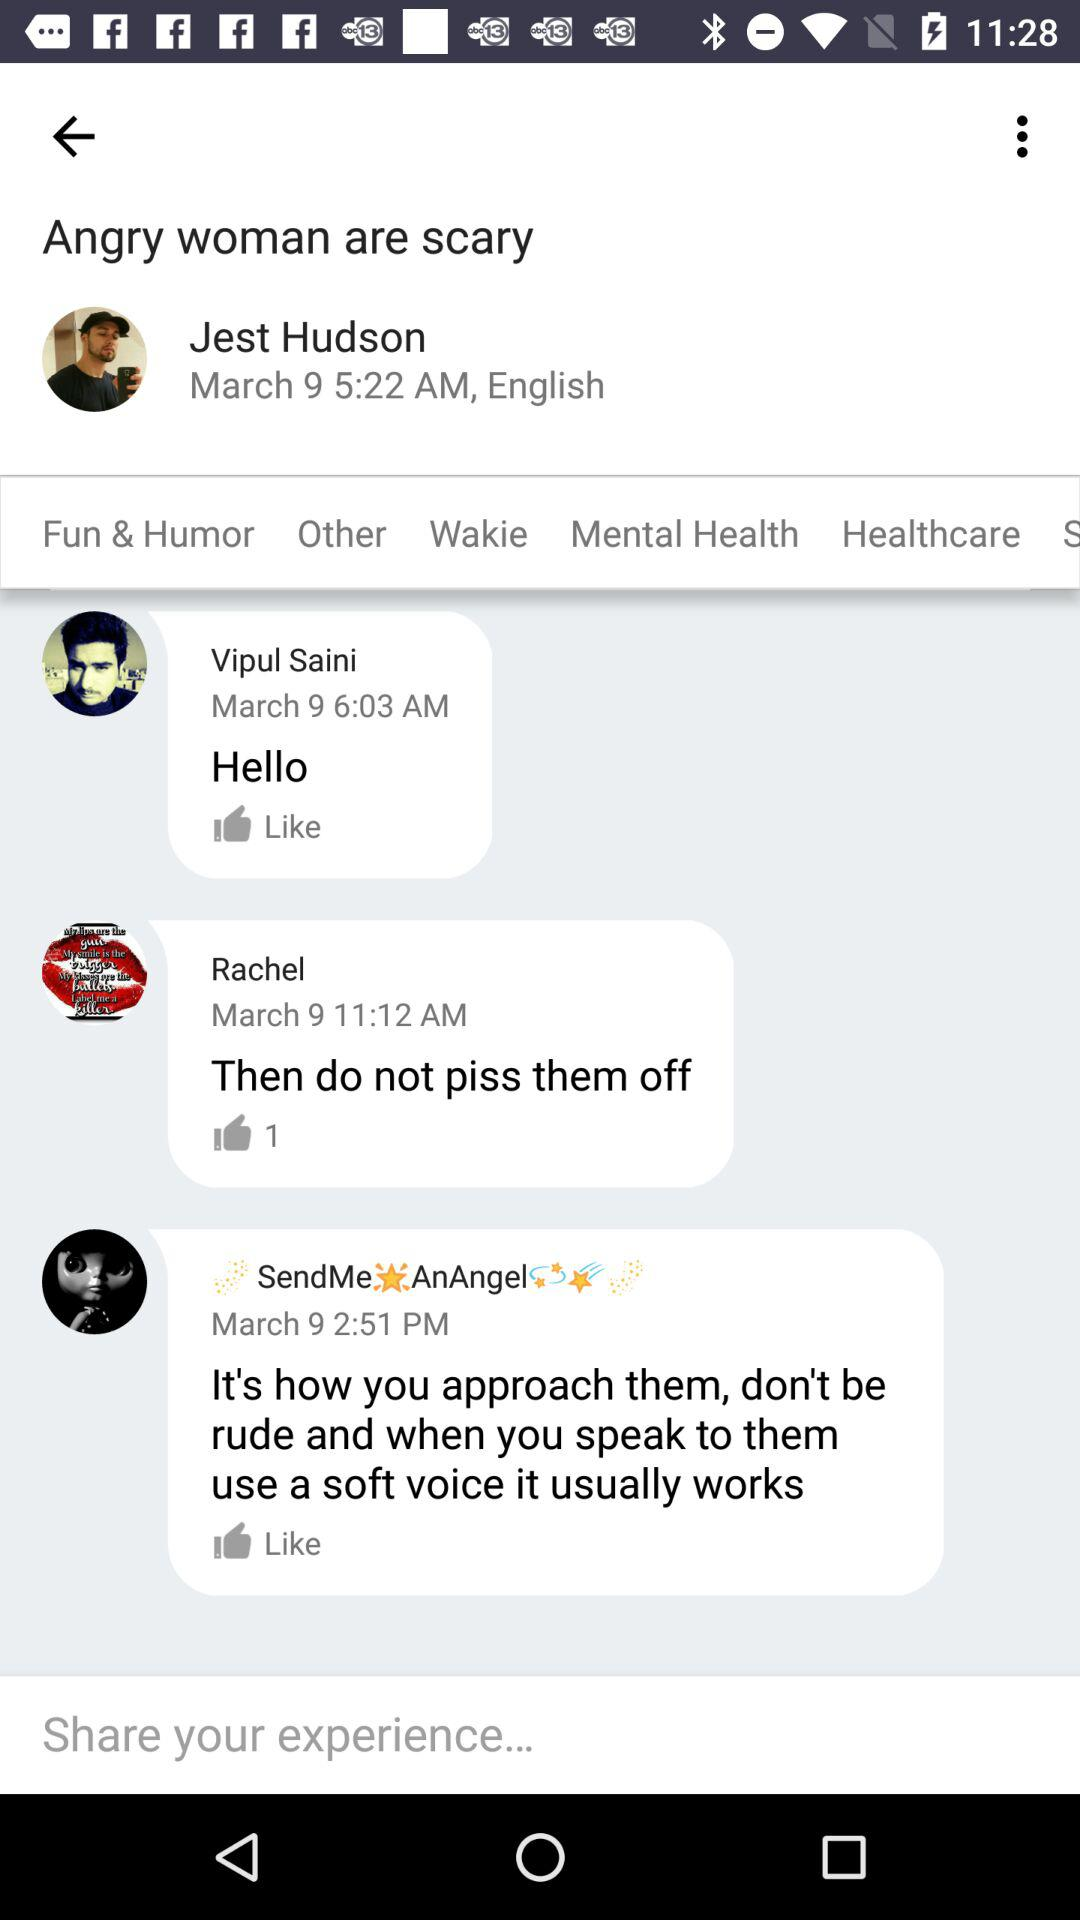How many likes does Rachel's comment receive? Rachel's comment received 1 like. 